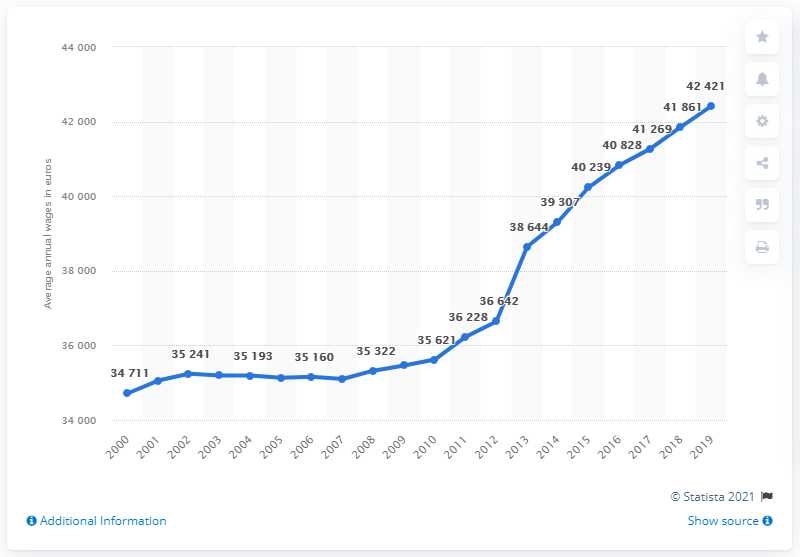Mention a couple of crucial points in this snapshot. As of 2019, the average annual wage in Germany was approximately 42,421 euros. Wages increased significantly from 2000 to 2007, with a value of 42,421. 